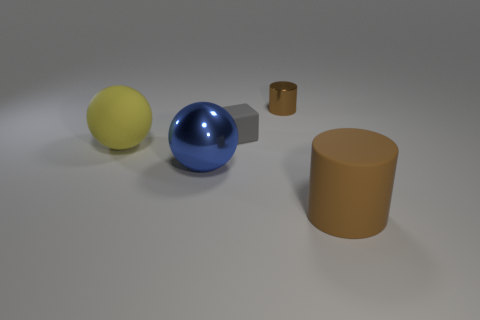What number of big brown things are on the right side of the large rubber object that is right of the yellow sphere?
Keep it short and to the point. 0. What is the material of the other sphere that is the same size as the shiny sphere?
Give a very brief answer. Rubber. How many other things are there of the same material as the small gray block?
Make the answer very short. 2. How many tiny metallic cylinders are to the left of the block?
Provide a short and direct response. 0. How many spheres are blue shiny objects or tiny rubber things?
Your response must be concise. 1. What size is the thing that is both to the right of the gray rubber object and in front of the tiny gray rubber object?
Your answer should be very brief. Large. What number of other objects are there of the same color as the matte cylinder?
Your answer should be very brief. 1. Does the tiny gray object have the same material as the cylinder left of the brown matte cylinder?
Provide a succinct answer. No. How many things are objects that are behind the gray rubber object or tiny blue metallic cylinders?
Offer a very short reply. 1. What shape is the thing that is both in front of the gray object and right of the small rubber thing?
Provide a succinct answer. Cylinder. 